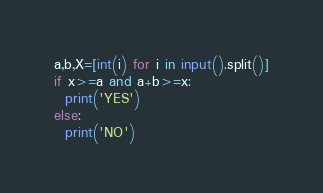<code> <loc_0><loc_0><loc_500><loc_500><_Python_>a,b,X=[int(i) for i in input().split()]
if x>=a and a+b>=x:
  print('YES')
else:
  print('NO')</code> 